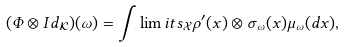Convert formula to latex. <formula><loc_0><loc_0><loc_500><loc_500>( \Phi \otimes I d _ { \mathcal { K } } ) ( \omega ) = \int \lim i t s _ { \mathcal { X } } \rho ^ { \prime } ( x ) \otimes \sigma _ { \omega } ( x ) \mu _ { \omega } ( d x ) ,</formula> 